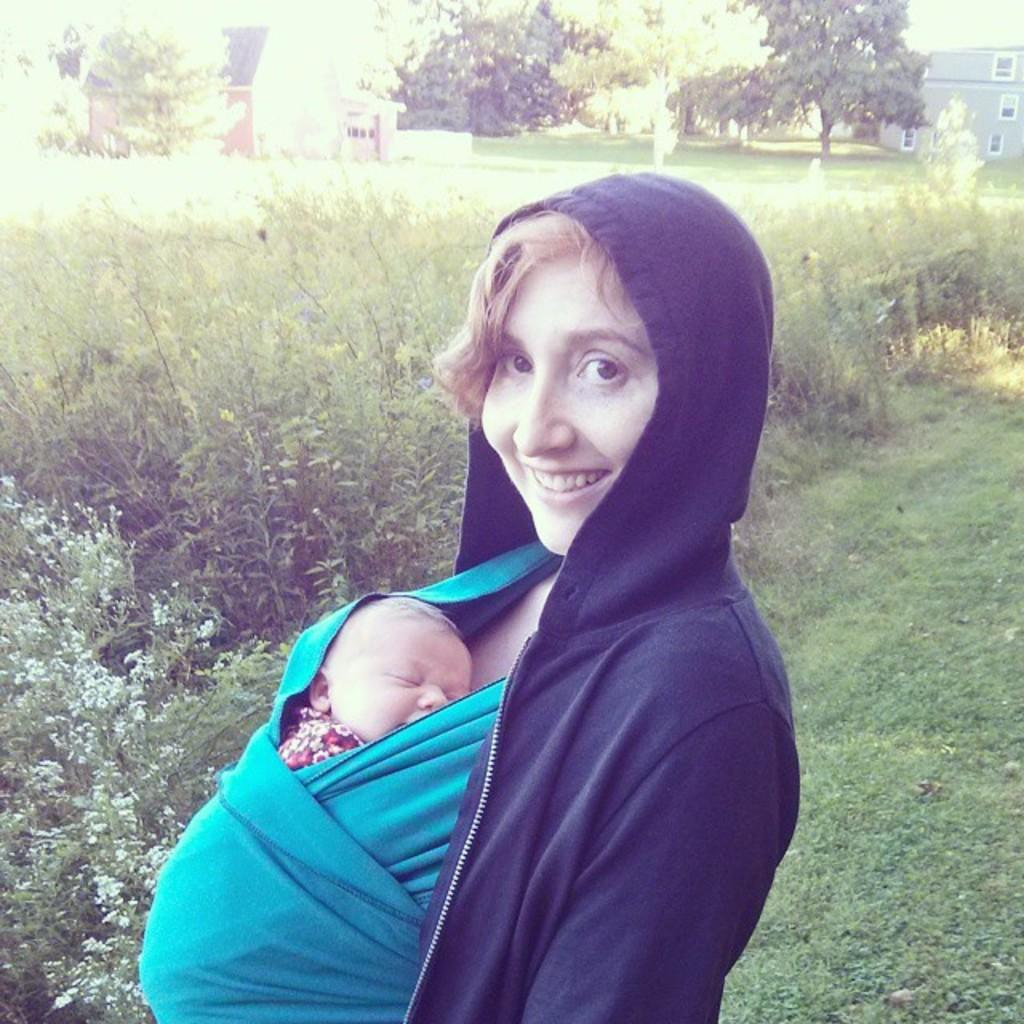Who is the main subject in the center of the image? There is a lady in the center of the image. What is the lady doing in the image? The lady is smiling and holding a baby. What can be seen in the background of the image? There are buildings, trees, and plants visible in the background of the image. What is at the bottom of the image? There is ground at the bottom of the image. What type of pies can be seen in the image? There are no pies present in the image. Is there a donkey visible in the image? No, there is no donkey present in the image. 